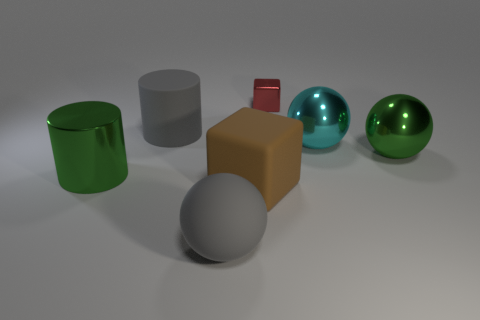There is a red thing that is made of the same material as the large cyan ball; what is its shape?
Your response must be concise. Cube. There is a cube that is in front of the large green sphere on the right side of the red block; what is its size?
Make the answer very short. Large. What is the shape of the large brown rubber thing?
Provide a short and direct response. Cube. How many big things are either brown rubber objects or yellow matte cylinders?
Offer a terse response. 1. What is the size of the rubber thing that is the same shape as the red metallic object?
Your answer should be very brief. Large. How many big objects are left of the tiny object and to the right of the green shiny cylinder?
Your answer should be very brief. 3. There is a red object; does it have the same shape as the big matte thing that is right of the gray sphere?
Provide a short and direct response. Yes. Are there more large cyan spheres to the right of the big green metal cylinder than small green matte cylinders?
Offer a very short reply. Yes. Is the number of gray matte cylinders that are to the right of the big green sphere less than the number of tiny brown shiny things?
Offer a very short reply. No. How many large rubber cylinders are the same color as the metallic cylinder?
Give a very brief answer. 0. 